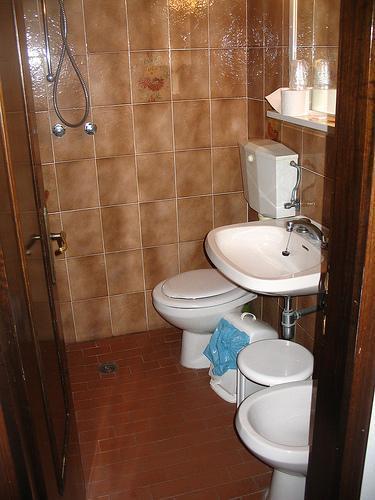How many sinks are there?
Give a very brief answer. 1. 